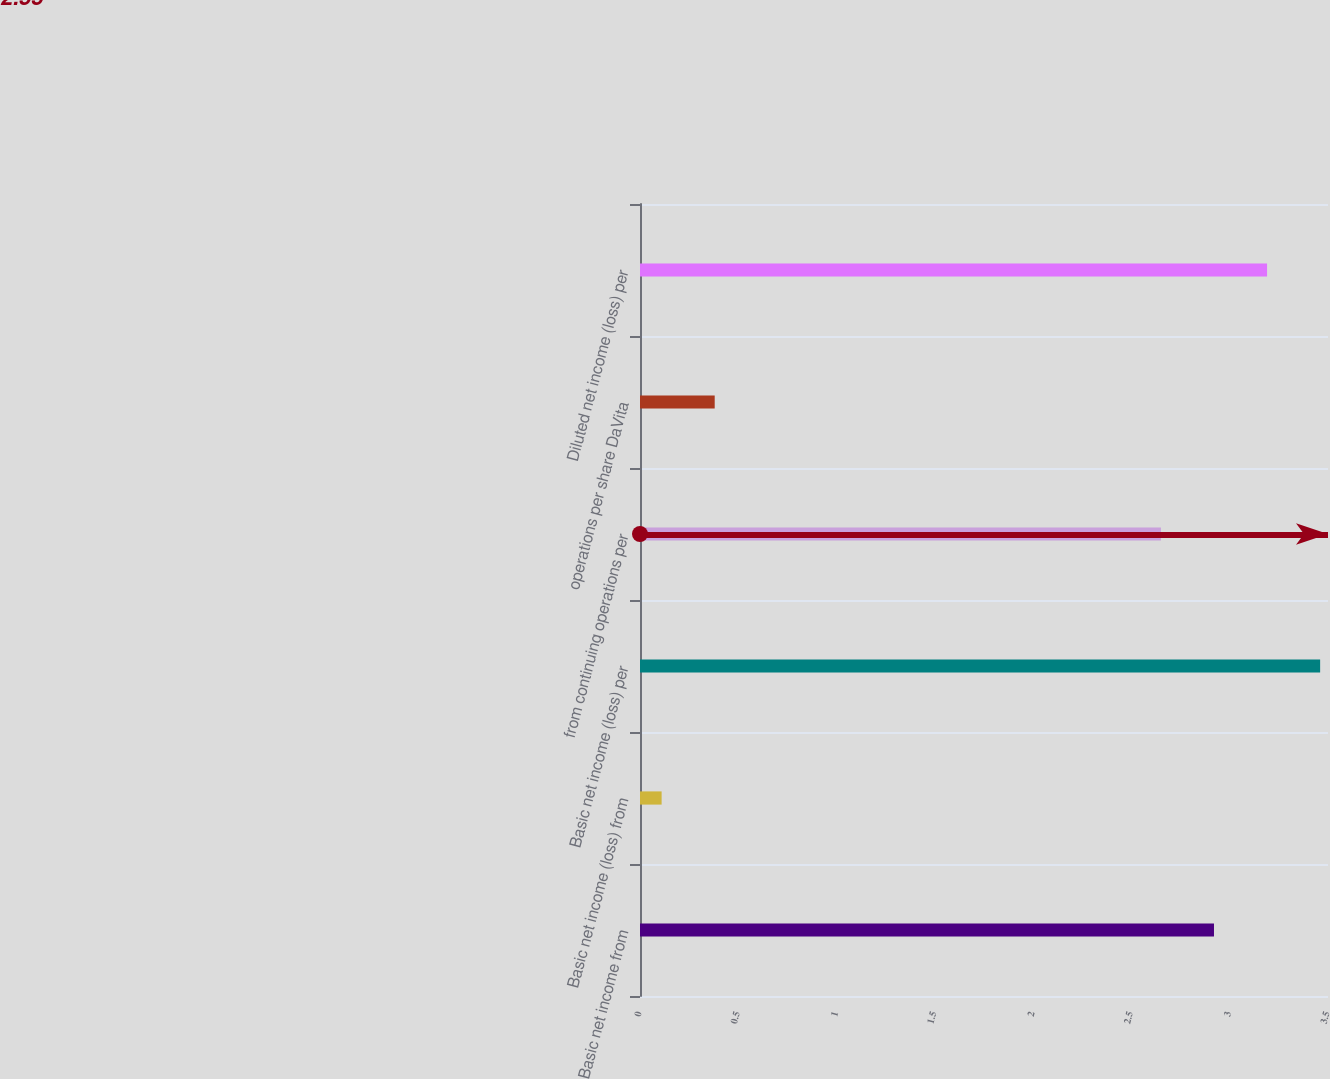Convert chart to OTSL. <chart><loc_0><loc_0><loc_500><loc_500><bar_chart><fcel>Basic net income from<fcel>Basic net income (loss) from<fcel>Basic net income (loss) per<fcel>from continuing operations per<fcel>operations per share DaVita<fcel>Diluted net income (loss) per<nl><fcel>2.92<fcel>0.11<fcel>3.46<fcel>2.65<fcel>0.38<fcel>3.19<nl></chart> 